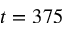<formula> <loc_0><loc_0><loc_500><loc_500>t = 3 7 5</formula> 